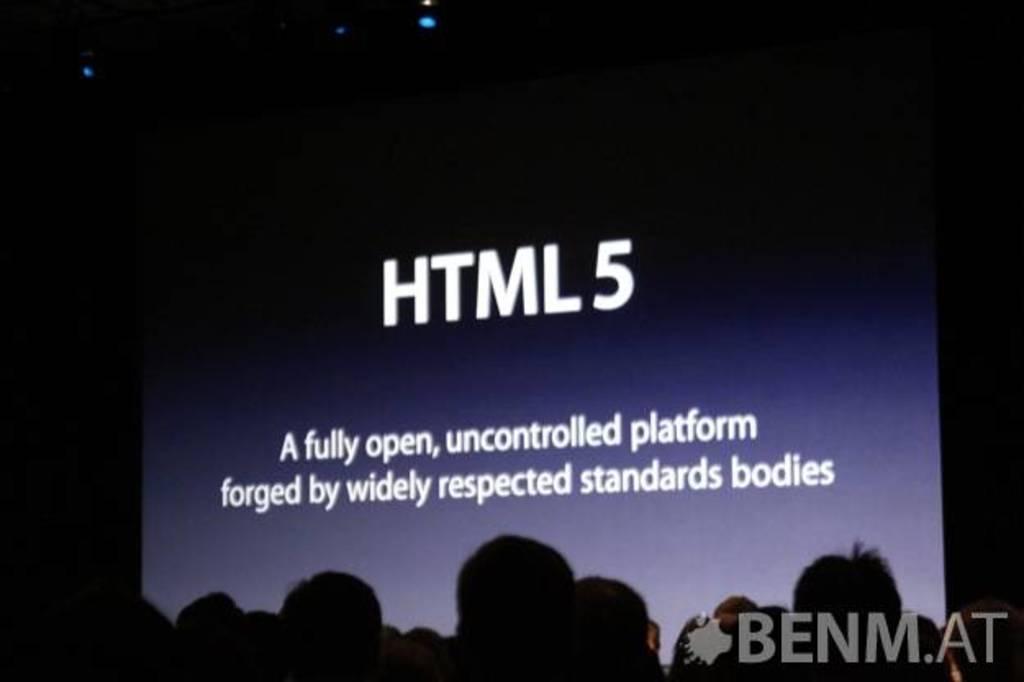In one or two sentences, can you explain what this image depicts? In this image we can see there are people and in front of them there is a screen with text. 